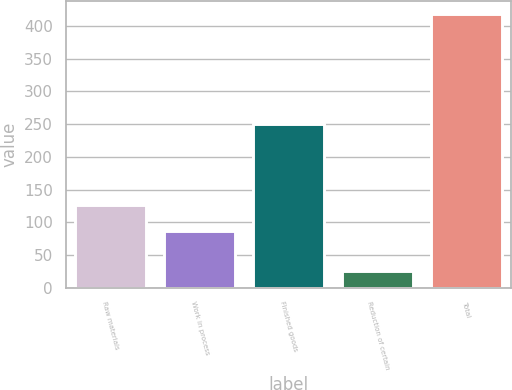Convert chart. <chart><loc_0><loc_0><loc_500><loc_500><bar_chart><fcel>Raw materials<fcel>Work in process<fcel>Finished goods<fcel>Reduction of certain<fcel>Total<nl><fcel>126.5<fcel>87.2<fcel>249.5<fcel>24.9<fcel>417.9<nl></chart> 